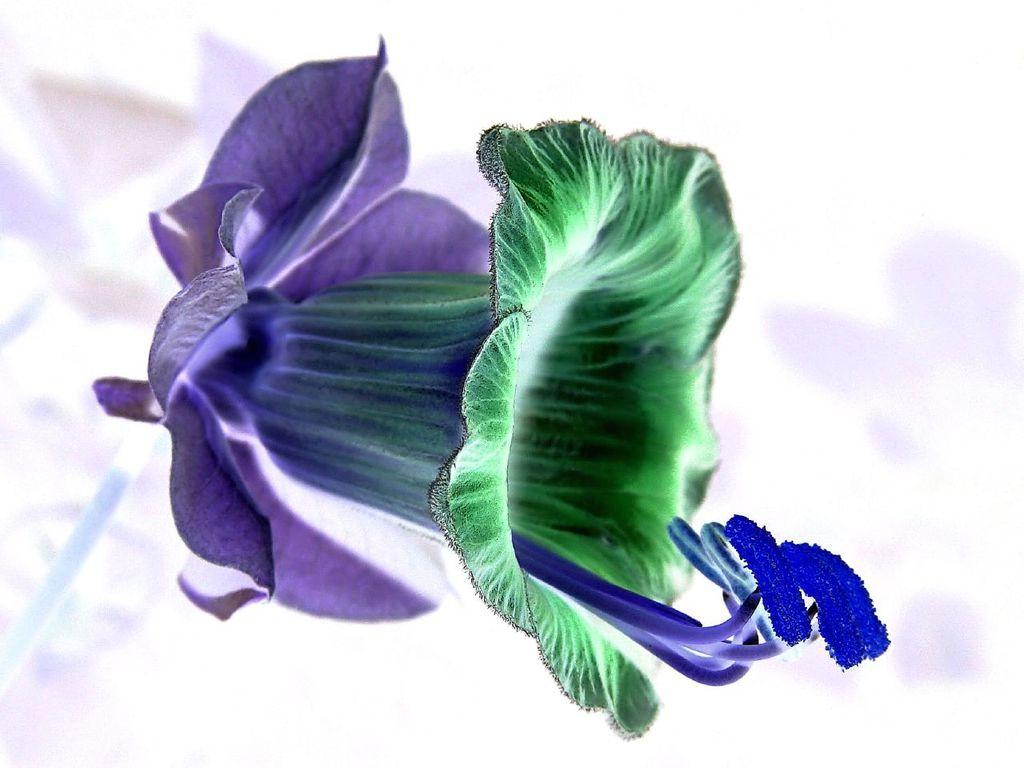What is the main subject of the image? There is a flower in the image. What colors can be seen on the flower? The flower has green and blue colors. Can you describe the background of the image? The background of the image is blurred. Can you tell me how many tanks are visible in the image? There are no tanks present in the image; it features a flower with green and blue colors. Is there a stream flowing through the flower in the image? There is no stream present in the image; it features a flower with green and blue colors. --- Facts: 1. There is a person holding a camera in the image. 2. The person is wearing a hat. 3. The background of the image is a cityscape. 4. There are buildings in the background of the image. Absurd Topics: elephant, ocean, volcano Conversation: What is the person in the image doing? The person is holding a camera in the image. Can you describe the person's attire in the image? The person is wearing a hat. What can be seen in the background of the image? The background of the image is a cityscape, and there are buildings visible. Reasoning: Let's think step by step in order to produce the conversation. We start by identifying the main subject of the image, which is the person holding a camera. Next, we describe the person's attire, which includes a hat. Finally, we describe the background of the image, which is a cityscape with visible buildings. Absurd Question/Answer: Can you tell me how many elephants are visible in the image? There are no elephants present in the image; it features a person holding a camera and wearing a hat, with a cityscape background. Is there an ocean visible in the background of the image? There is no ocean present in the image; it features a person holding a camera and wearing a hat, with a cityscape background. --- Facts: 1. There is a person sitting on a bench in the image. 2. The person is reading a book. 3. The background of the image is a park. 4. There are trees in the background of the image. Absurd Topics: parrot, sand, surfboard Conversation: What is the person in the image doing? The person is sitting on a bench in the image. What activity is the person engaged in while sitting on the bench? The person is reading a book. What can be seen in the background of the image? The background of the image is a park, and there are trees visible. Reasoning: Let's think step by step in order to produce the conversation. We start by identifying the main subject of the image, which is the person sitting on a bench. Next, we describe the activity the person is engaged in, which is reading a book. Finally, we describe the background of the image, which 